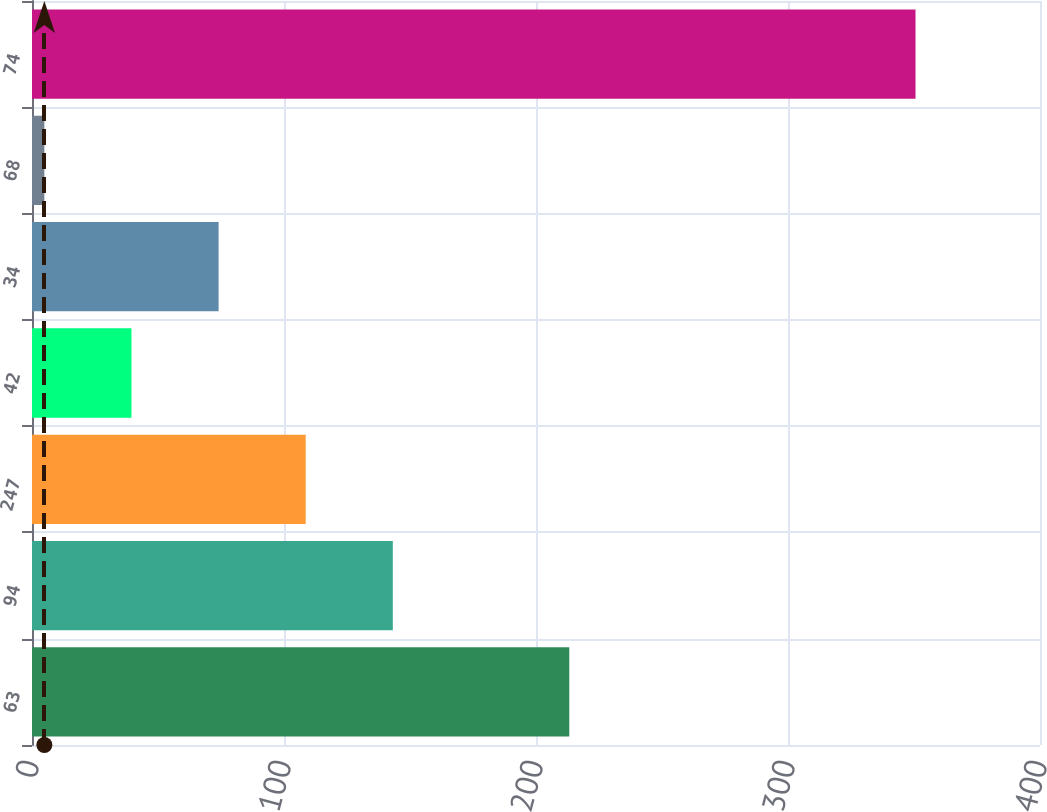Convert chart. <chart><loc_0><loc_0><loc_500><loc_500><bar_chart><fcel>63<fcel>94<fcel>247<fcel>42<fcel>34<fcel>68<fcel>74<nl><fcel>213.2<fcel>143.18<fcel>108.61<fcel>39.47<fcel>74.04<fcel>4.9<fcel>350.6<nl></chart> 